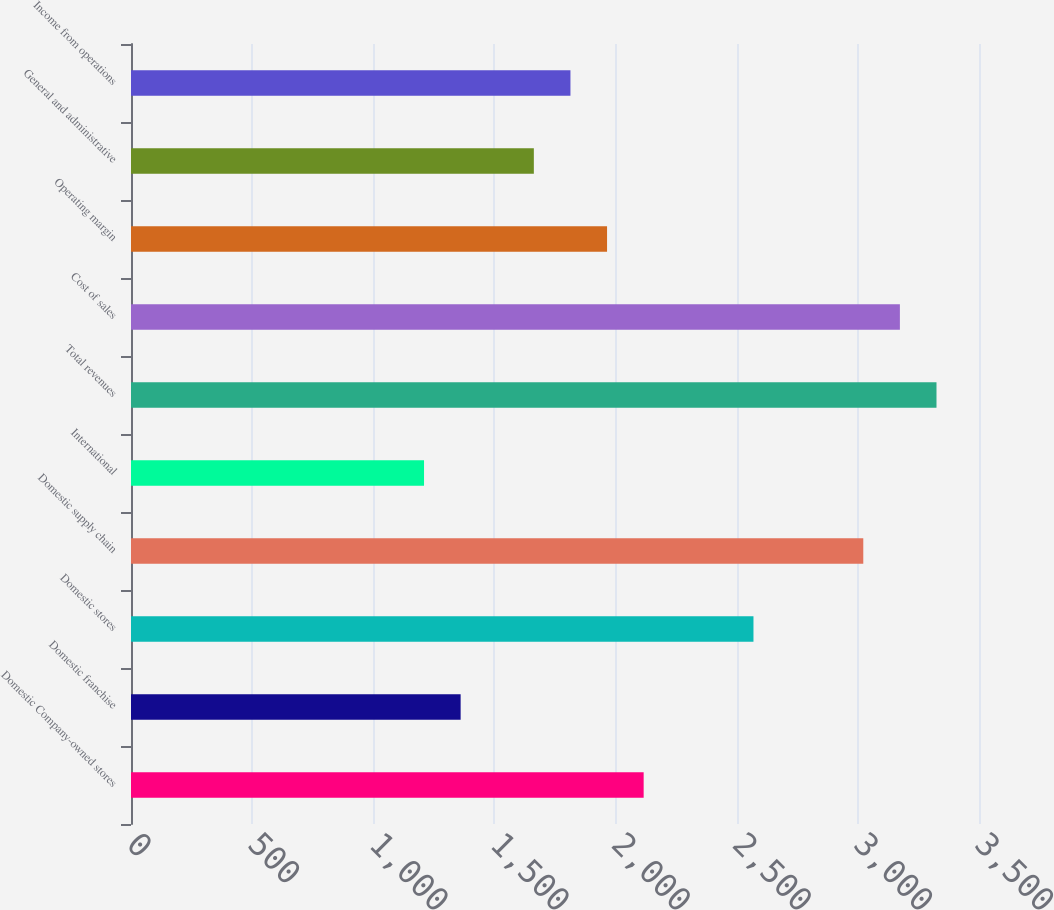Convert chart to OTSL. <chart><loc_0><loc_0><loc_500><loc_500><bar_chart><fcel>Domestic Company-owned stores<fcel>Domestic franchise<fcel>Domestic stores<fcel>Domestic supply chain<fcel>International<fcel>Total revenues<fcel>Cost of sales<fcel>Operating margin<fcel>General and administrative<fcel>Income from operations<nl><fcel>2115.92<fcel>1360.52<fcel>2569.16<fcel>3022.4<fcel>1209.44<fcel>3324.56<fcel>3173.48<fcel>1964.84<fcel>1662.68<fcel>1813.76<nl></chart> 